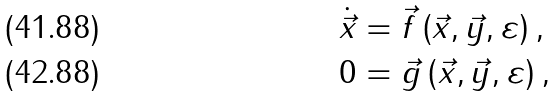Convert formula to latex. <formula><loc_0><loc_0><loc_500><loc_500>\dot { \vec { x } } & = \vec { f } \left ( { \vec { x } , \vec { y } , \varepsilon } \right ) , \\ 0 & = \vec { g } \left ( { \vec { x } , \vec { y } , \varepsilon } \right ) ,</formula> 